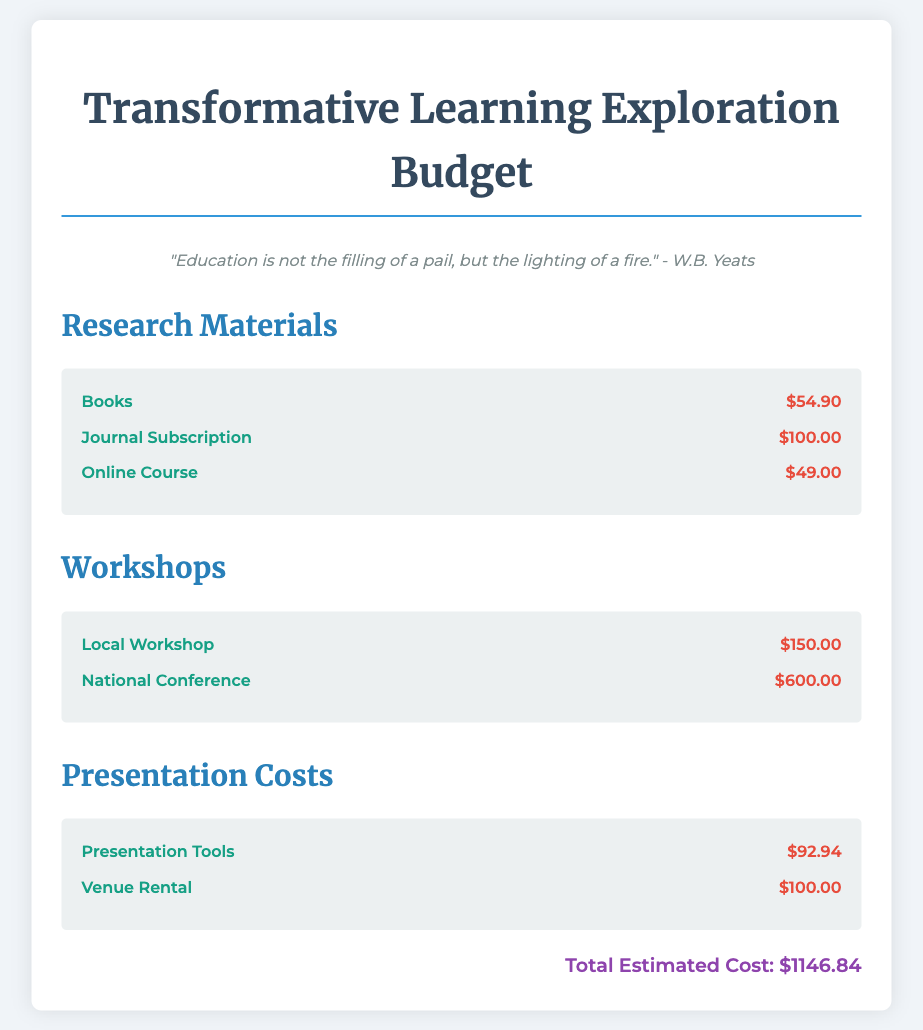What is the total estimated cost? The total estimated cost is summarized at the bottom of the document, which includes all the allocations made for research materials, workshops, and presentation costs.
Answer: $1146.84 How much is allocated for books? The allocation for books is listed under research materials, showing the specific cost of purchasing books for the project.
Answer: $54.90 What is the cost of the national conference? The cost of the national conference is included in the workshops section, detailing the expenses associated with attending this event.
Answer: $600.00 How much do the presentation tools cost? The cost of the presentation tools is provided in the presentation costs section, indicating how much is budgeted for the necessary equipment.
Answer: $92.94 What is the total cost for workshops? The total cost for workshops can be calculated by adding the costs of the local workshop and the national conference, reflecting the total budget for these events.
Answer: $750.00 How many research materials are listed? The number of research materials is derived from the items listed under the research materials section in the document, showing all acquisitions planned for the project.
Answer: 3 What is the cost of the journal subscription? The cost of the journal subscription is one of the listed expenses under research materials, specifying the amount budgeted for subscribing to academic journals.
Answer: $100.00 Is there a quote in the document? The document includes a quote from W.B. Yeats that emphasizes the philosophy behind the project, illustrating its educational approach.
Answer: Yes 